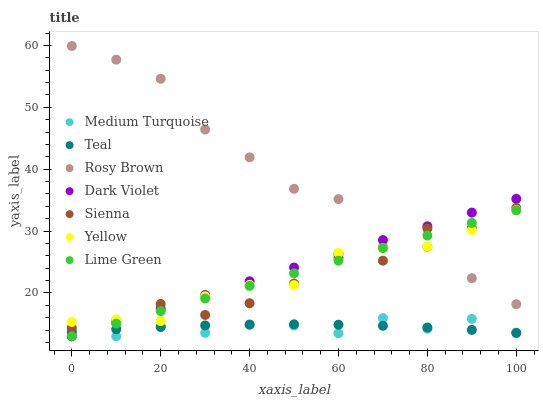Does Medium Turquoise have the minimum area under the curve?
Answer yes or no. Yes. Does Rosy Brown have the maximum area under the curve?
Answer yes or no. Yes. Does Dark Violet have the minimum area under the curve?
Answer yes or no. No. Does Dark Violet have the maximum area under the curve?
Answer yes or no. No. Is Dark Violet the smoothest?
Answer yes or no. Yes. Is Rosy Brown the roughest?
Answer yes or no. Yes. Is Rosy Brown the smoothest?
Answer yes or no. No. Is Dark Violet the roughest?
Answer yes or no. No. Does Medium Turquoise have the lowest value?
Answer yes or no. Yes. Does Rosy Brown have the lowest value?
Answer yes or no. No. Does Rosy Brown have the highest value?
Answer yes or no. Yes. Does Dark Violet have the highest value?
Answer yes or no. No. Is Medium Turquoise less than Sienna?
Answer yes or no. Yes. Is Yellow greater than Medium Turquoise?
Answer yes or no. Yes. Does Medium Turquoise intersect Dark Violet?
Answer yes or no. Yes. Is Medium Turquoise less than Dark Violet?
Answer yes or no. No. Is Medium Turquoise greater than Dark Violet?
Answer yes or no. No. Does Medium Turquoise intersect Sienna?
Answer yes or no. No. 